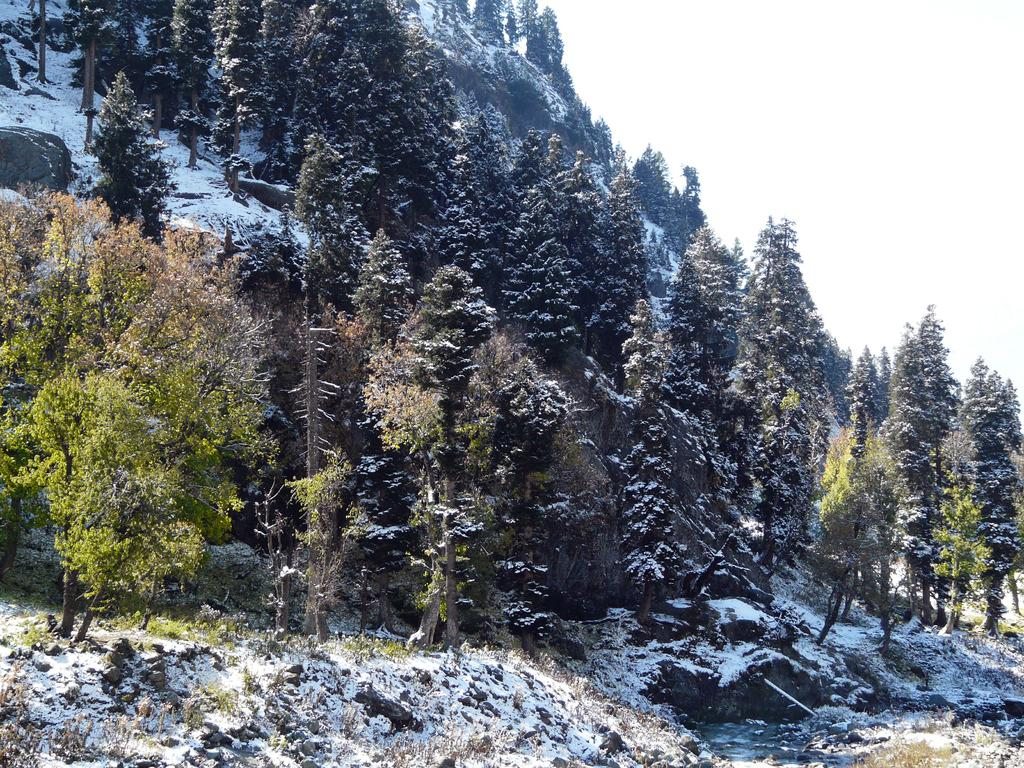What type of weather is depicted in the image? There is snow in the image, indicating cold weather. What geographical features can be seen in the image? There are hills and trees visible in the image. What part of the natural environment is visible in the image? The ground and the sky are visible in the image. What type of drum can be seen in the image? There is no drum present in the image. What is the kettle used for in the image? There is no kettle present in the image. 